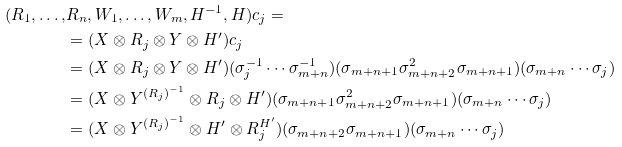Convert formula to latex. <formula><loc_0><loc_0><loc_500><loc_500>( R _ { 1 } , \dots , & R _ { n } , W _ { 1 } , \dots , W _ { m } , H ^ { - 1 } , H ) c _ { j } = \\ & = ( X \otimes R _ { j } \otimes Y \otimes H ^ { \prime } ) c _ { j } \\ & = ( X \otimes R _ { j } \otimes Y \otimes H ^ { \prime } ) ( \sigma _ { j } ^ { - 1 } \cdots \sigma _ { m + n } ^ { - 1 } ) ( \sigma _ { m + n + 1 } \sigma _ { m + n + 2 } ^ { 2 } \sigma _ { m + n + 1 } ) ( \sigma _ { m + n } \cdots \sigma _ { j } ) \\ & = ( X \otimes Y ^ { ( R _ { j } ) ^ { - 1 } } \otimes R _ { j } \otimes H ^ { \prime } ) ( \sigma _ { m + n + 1 } \sigma _ { m + n + 2 } ^ { 2 } \sigma _ { m + n + 1 } ) ( \sigma _ { m + n } \cdots \sigma _ { j } ) \\ & = ( X \otimes Y ^ { ( R _ { j } ) ^ { - 1 } } \otimes H ^ { \prime } \otimes R _ { j } ^ { H ^ { \prime } } ) ( \sigma _ { m + n + 2 } \sigma _ { m + n + 1 } ) ( \sigma _ { m + n } \cdots \sigma _ { j } )</formula> 